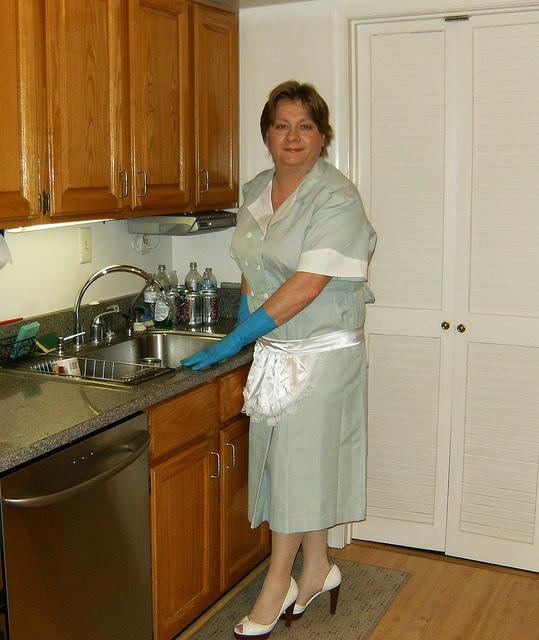Where may this lady be completing the cleaning? Please explain your reasoning. residence. There is a dishwasher. hotels don't have dishwashers. 